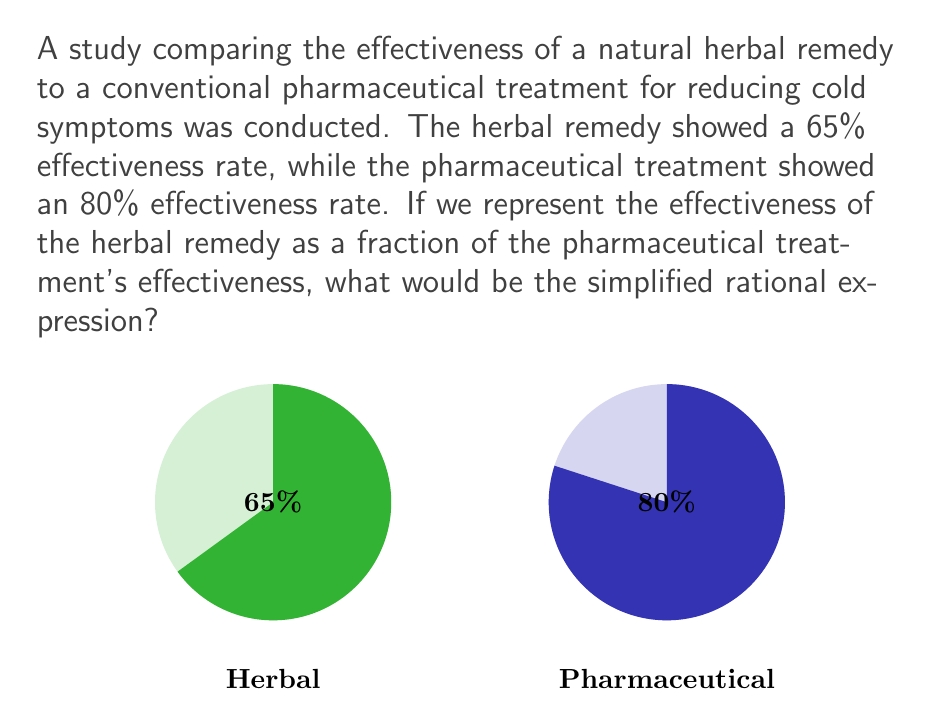Give your solution to this math problem. Let's approach this step-by-step:

1) We need to express the effectiveness of the herbal remedy as a fraction of the pharmaceutical treatment's effectiveness.

2) Herbal remedy effectiveness: 65%
   Pharmaceutical treatment effectiveness: 80%

3) To create a fraction, we put the herbal remedy's effectiveness in the numerator and the pharmaceutical treatment's effectiveness in the denominator:

   $$\frac{65\%}{80\%}$$

4) We can simplify this by canceling out the percentage symbols:

   $$\frac{65}{80}$$

5) To simplify this fraction, we need to find the greatest common divisor (GCD) of 65 and 80.
   
   65 = 5 × 13
   80 = 2^4 × 5

   The GCD is 5.

6) Dividing both the numerator and denominator by 5:

   $$\frac{65 \div 5}{80 \div 5} = \frac{13}{16}$$

This rational expression, $\frac{13}{16}$, represents the effectiveness of the herbal remedy as a fraction of the pharmaceutical treatment's effectiveness.
Answer: $\frac{13}{16}$ 